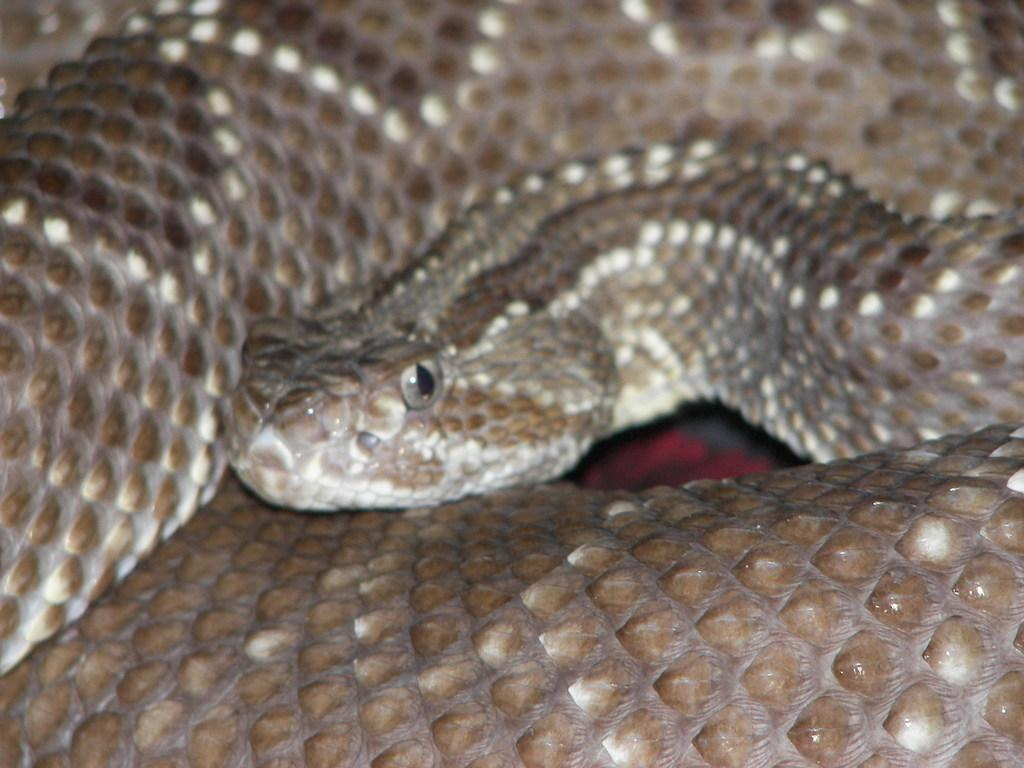What type of animal is present in the image? There is a snake in the image. What letters are visible on the snake's neck in the image? There are no letters visible on the snake's neck in the image, as snakes do not have necks or wear letters. 